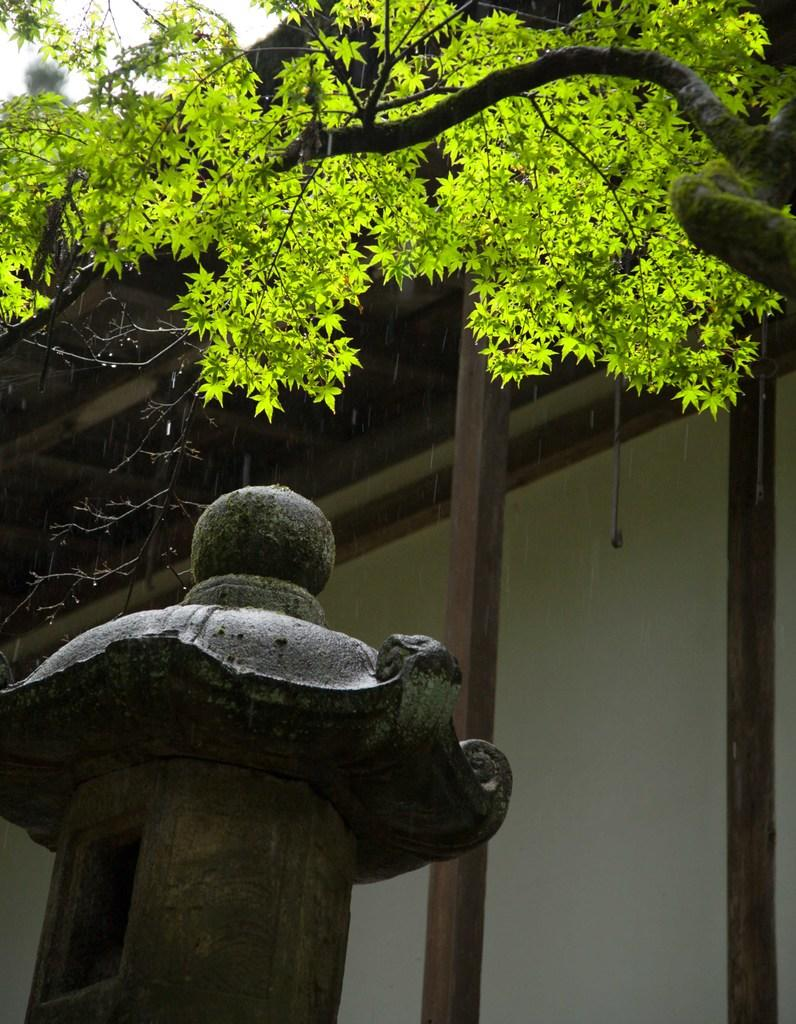What type of structure is visible in the image? There is a building in the image. What can be seen in front of the building? There is a tree in front of the building. How many rats can be seen climbing the tree in the image? There are no rats present in the image, and therefore no such activity can be observed. 